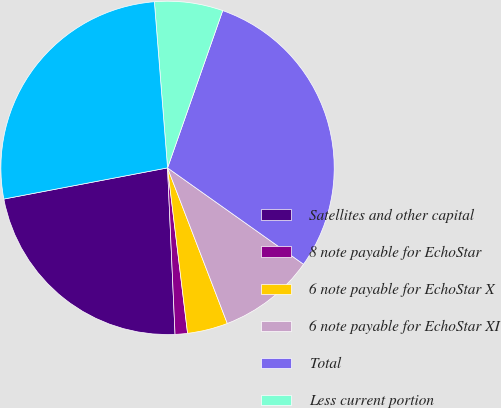Convert chart to OTSL. <chart><loc_0><loc_0><loc_500><loc_500><pie_chart><fcel>Satellites and other capital<fcel>8 note payable for EchoStar<fcel>6 note payable for EchoStar X<fcel>6 note payable for EchoStar XI<fcel>Total<fcel>Less current portion<fcel>Other long-term debt and<nl><fcel>22.72%<fcel>1.2%<fcel>3.92%<fcel>9.35%<fcel>29.44%<fcel>6.63%<fcel>26.73%<nl></chart> 